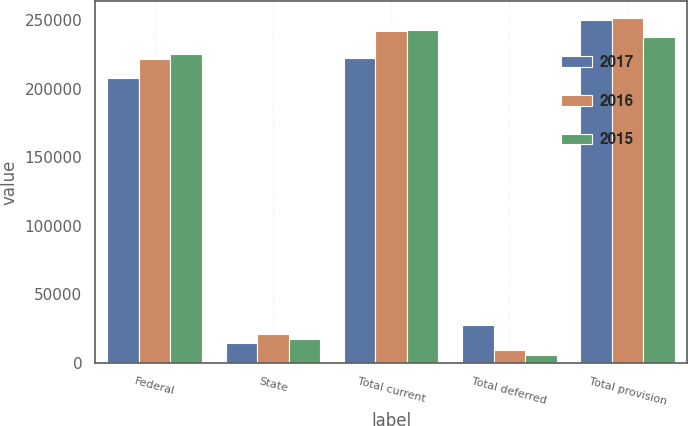Convert chart. <chart><loc_0><loc_0><loc_500><loc_500><stacked_bar_chart><ecel><fcel>Federal<fcel>State<fcel>Total current<fcel>Total deferred<fcel>Total provision<nl><fcel>2017<fcel>207986<fcel>14516<fcel>222502<fcel>27422<fcel>249924<nl><fcel>2016<fcel>221207<fcel>20858<fcel>242065<fcel>9085<fcel>251150<nl><fcel>2015<fcel>225253<fcel>17419<fcel>242672<fcel>5450<fcel>237222<nl></chart> 